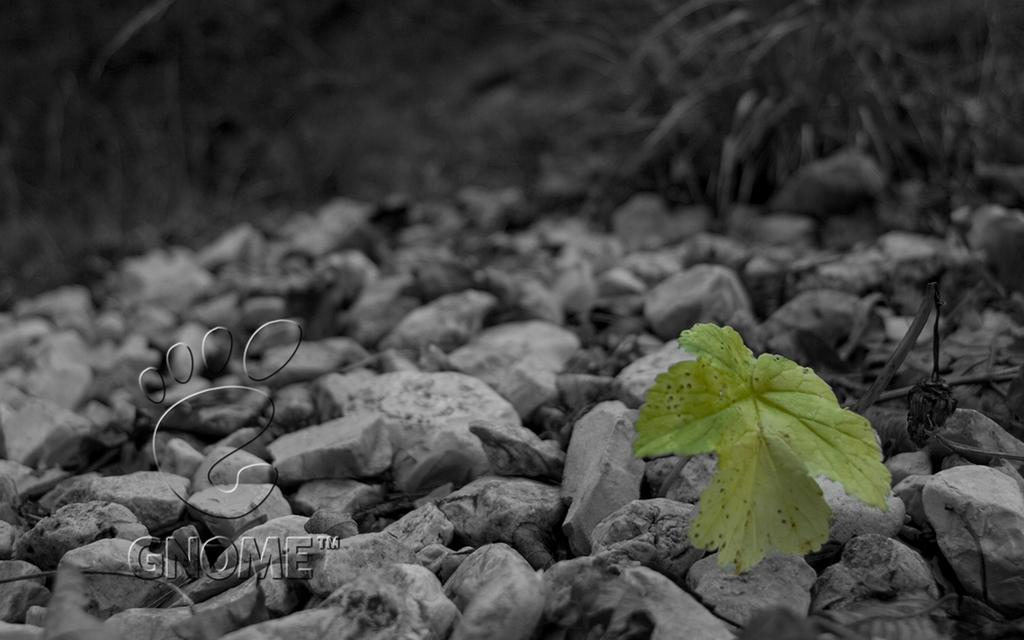What type of plant material is present in the image? There is a leaf in the image. What other objects can be seen in the image? There are stones visible in the image. What celestial bodies are visible in the image? There are planets visible in the image. How would you describe the background of the image? The background of the image is blurred. Is the porter carrying a plant in the image? There is no porter present in the image, so it is not possible to determine if they are carrying a plant. What type of book is the person reading in the image? There is no person reading a book in the image; the focus is on the leaf, stones, and planets. 